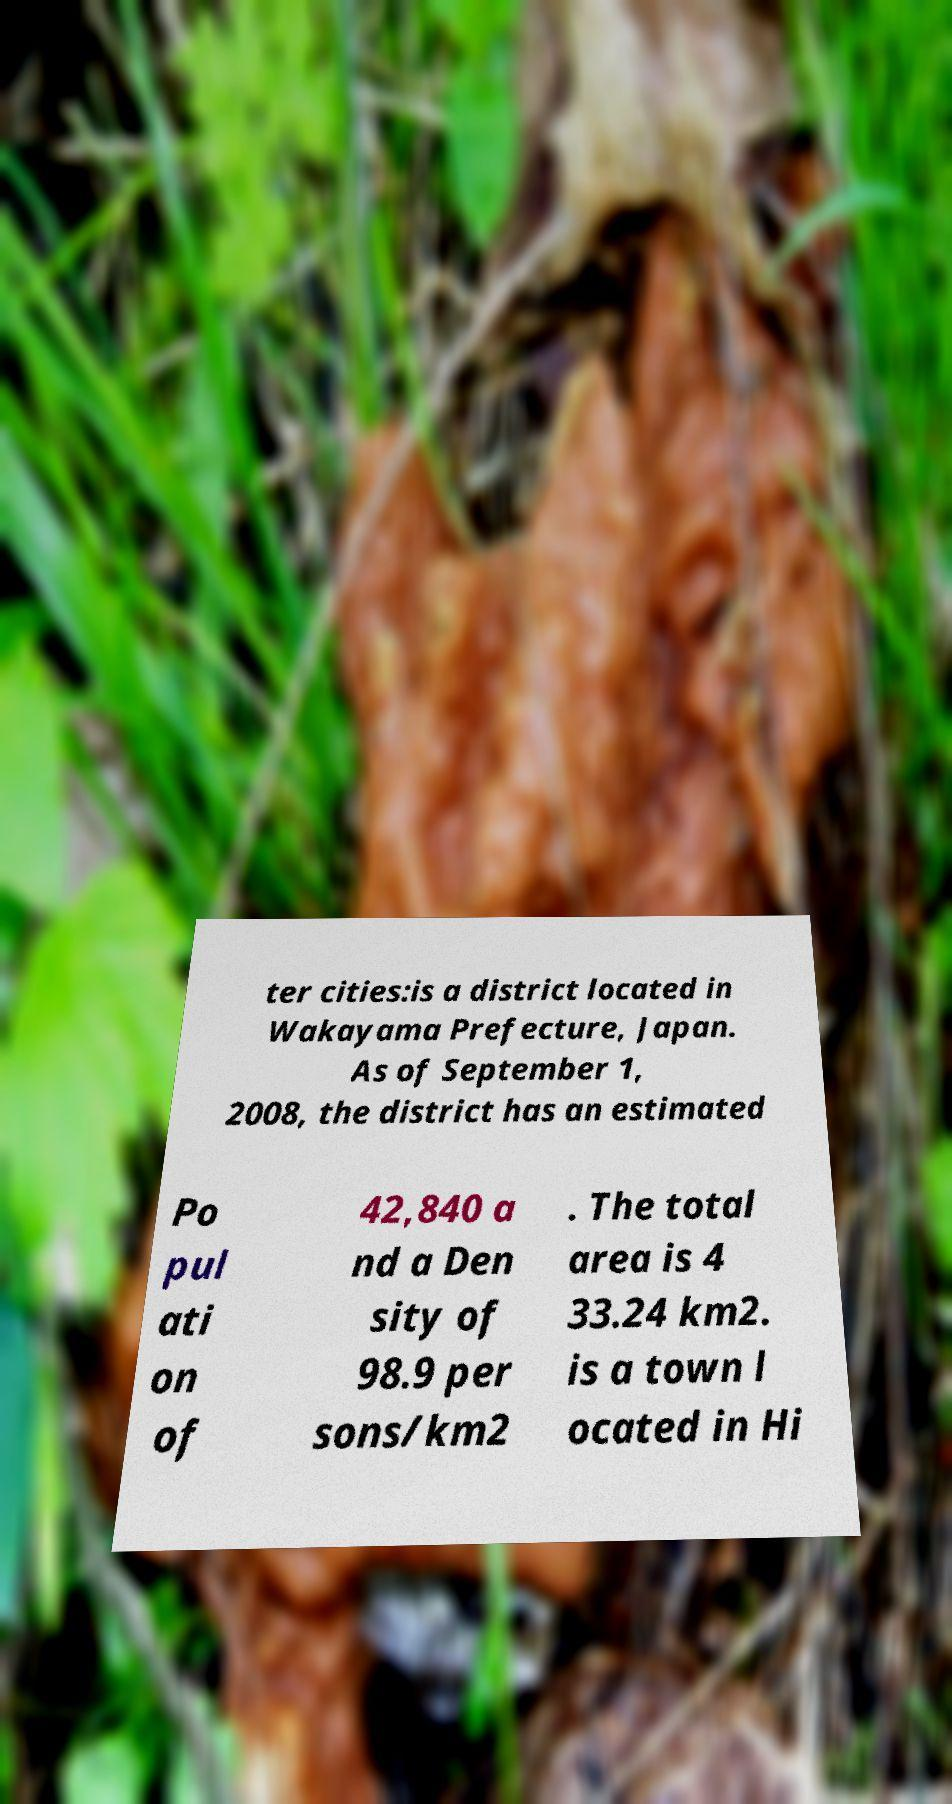Could you extract and type out the text from this image? ter cities:is a district located in Wakayama Prefecture, Japan. As of September 1, 2008, the district has an estimated Po pul ati on of 42,840 a nd a Den sity of 98.9 per sons/km2 . The total area is 4 33.24 km2. is a town l ocated in Hi 